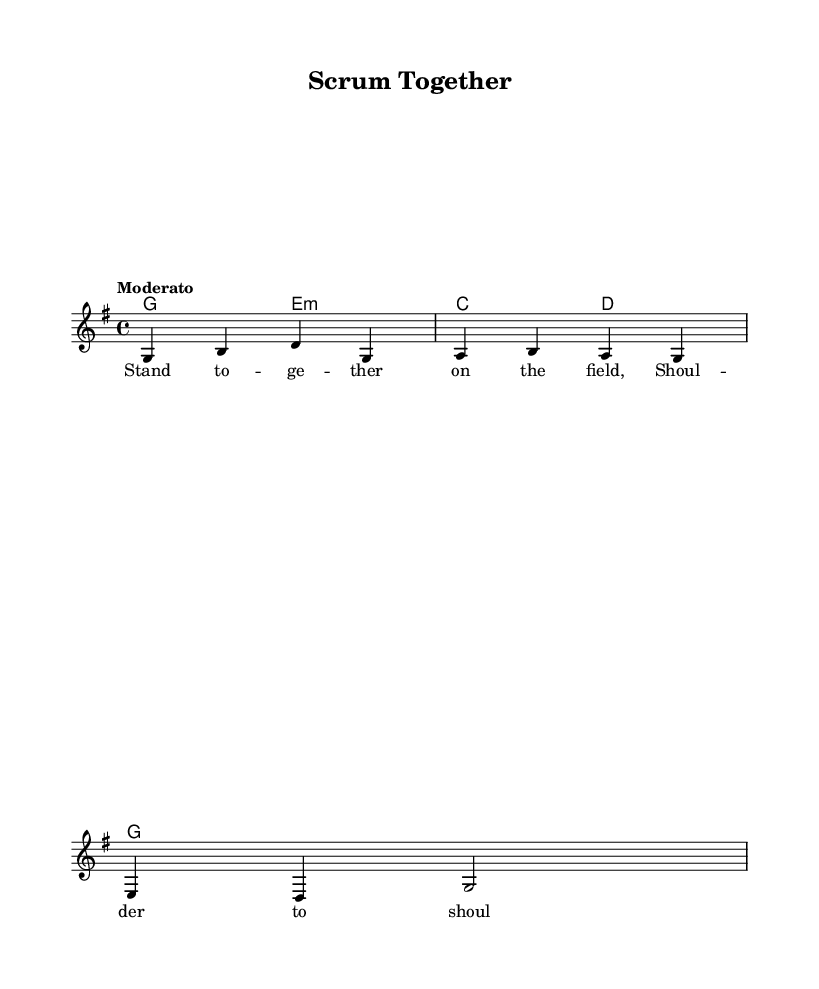What is the key signature of this music? The key signature is G major, which has one sharp (F#). This is indicated by the key signature notation placed at the beginning of the staff.
Answer: G major What is the time signature of the piece? The time signature is 4/4, which is indicated at the beginning of the score. This means there are four beats in each measure and the quarter note receives one beat.
Answer: 4/4 What is the tempo marking for this piece? The tempo marking is "Moderato," which suggests a moderate pace for the performance. This is located at the beginning of the score, just above the music staff.
Answer: Moderato How many measures are in the melody? The melody consists of 3 measures, as determined by counting the groupings separated by vertical bar lines in the score.
Answer: 3 What is the first lyric line of the song? The first lyric line is "Stand to--ge--ther on the field." This is derived from the lyrics indicated below the melody notes.
Answer: Stand together on the field Which chord is played for the first measure? The first measure features a G major chord, which is represented by the chord symbol 'G' above the melody notes.
Answer: G major What do the lyrics emphasize about teamwork? The lyrics emphasize camaraderie, as seen in phrases like "Shoulder to shoulder, we won't yield," highlighting the importance of working together. This thematic element captures the spirit of sportsmanship.
Answer: Camaraderie 